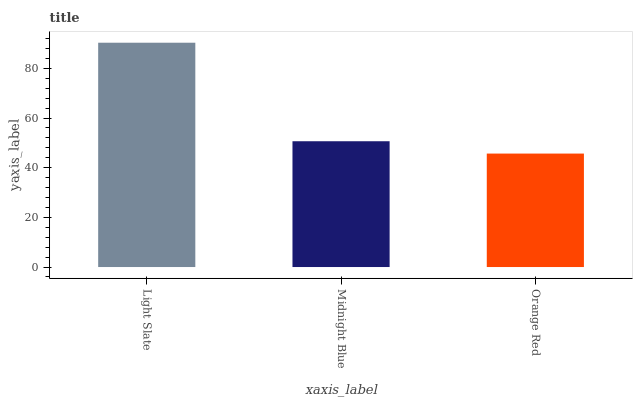Is Orange Red the minimum?
Answer yes or no. Yes. Is Light Slate the maximum?
Answer yes or no. Yes. Is Midnight Blue the minimum?
Answer yes or no. No. Is Midnight Blue the maximum?
Answer yes or no. No. Is Light Slate greater than Midnight Blue?
Answer yes or no. Yes. Is Midnight Blue less than Light Slate?
Answer yes or no. Yes. Is Midnight Blue greater than Light Slate?
Answer yes or no. No. Is Light Slate less than Midnight Blue?
Answer yes or no. No. Is Midnight Blue the high median?
Answer yes or no. Yes. Is Midnight Blue the low median?
Answer yes or no. Yes. Is Light Slate the high median?
Answer yes or no. No. Is Orange Red the low median?
Answer yes or no. No. 